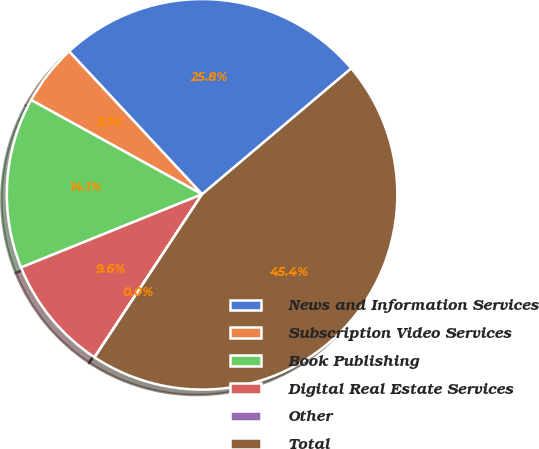Convert chart to OTSL. <chart><loc_0><loc_0><loc_500><loc_500><pie_chart><fcel>News and Information Services<fcel>Subscription Video Services<fcel>Book Publishing<fcel>Digital Real Estate Services<fcel>Other<fcel>Total<nl><fcel>25.77%<fcel>5.05%<fcel>14.14%<fcel>9.6%<fcel>0.01%<fcel>45.43%<nl></chart> 